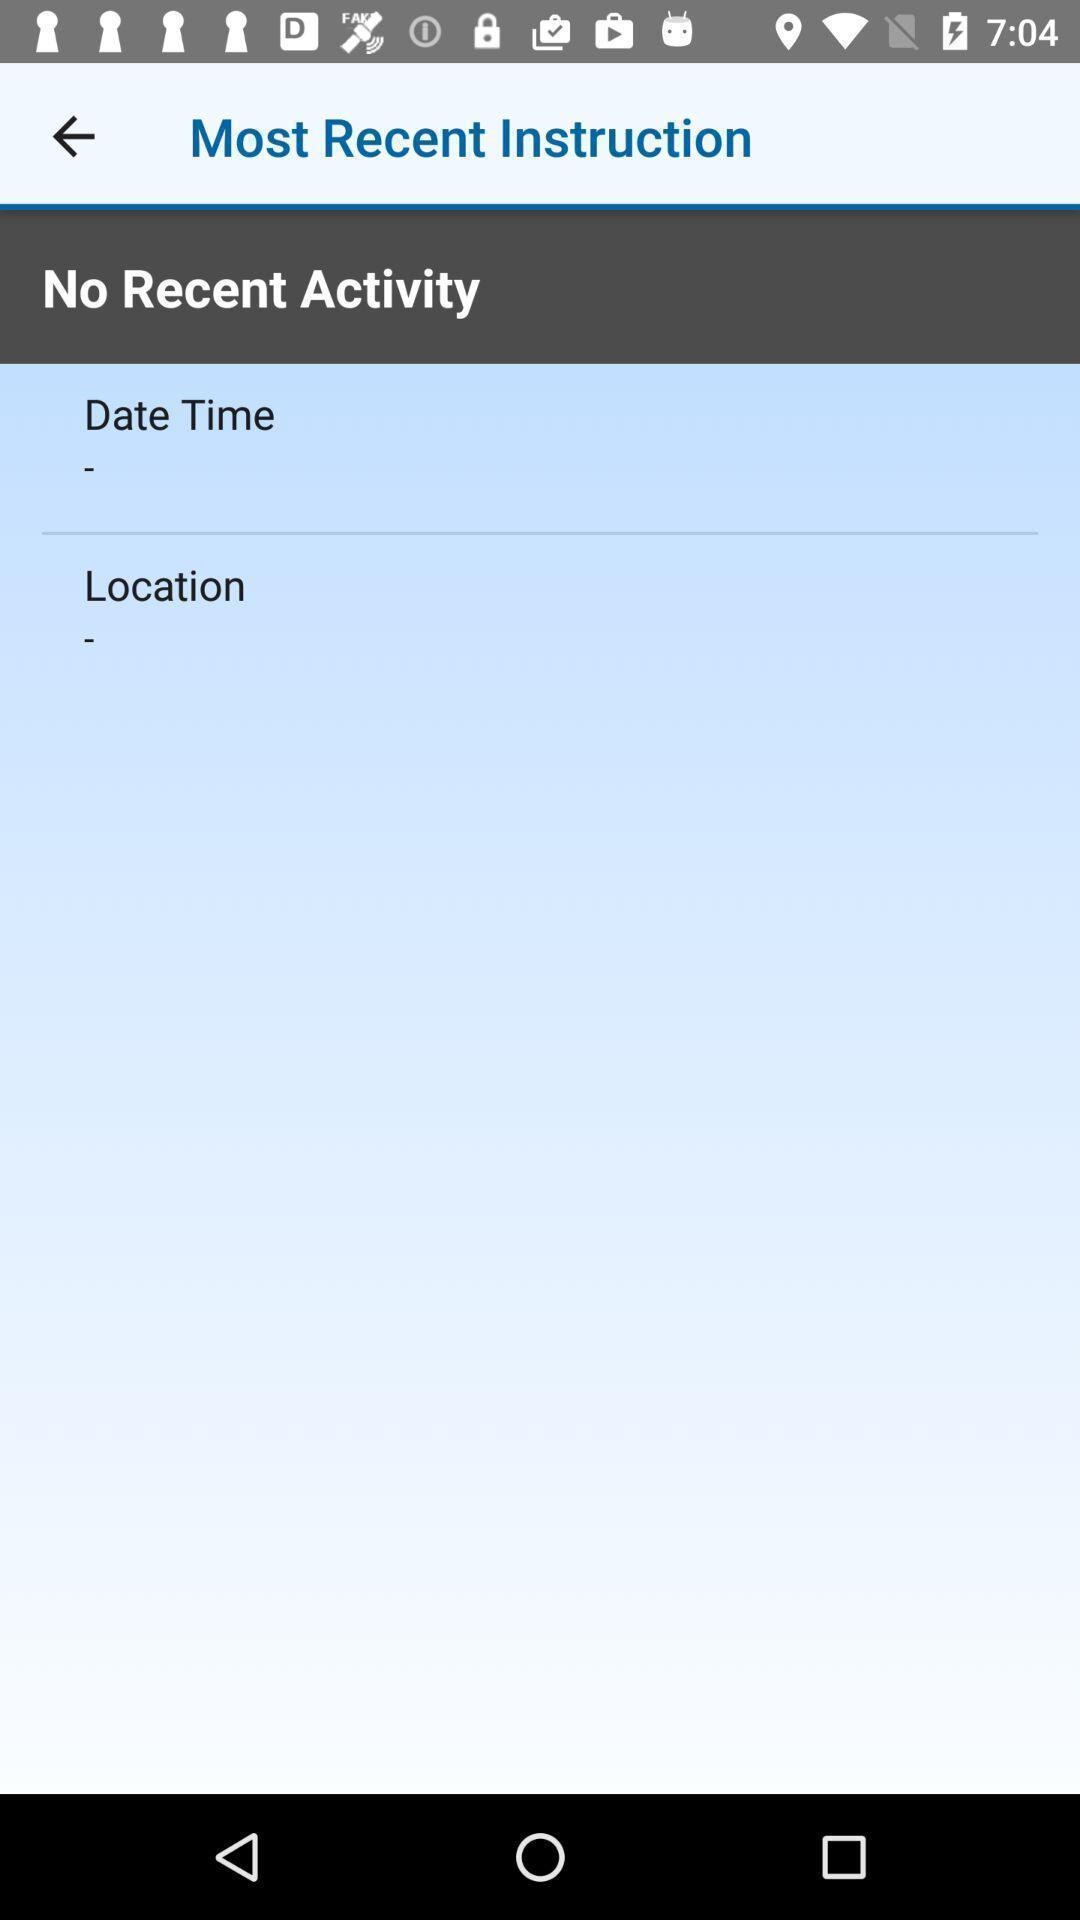Provide a detailed account of this screenshot. Screen showing recent activity page of a trucking app. 